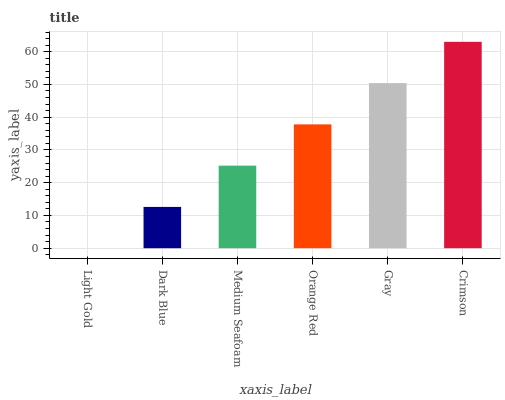Is Light Gold the minimum?
Answer yes or no. Yes. Is Crimson the maximum?
Answer yes or no. Yes. Is Dark Blue the minimum?
Answer yes or no. No. Is Dark Blue the maximum?
Answer yes or no. No. Is Dark Blue greater than Light Gold?
Answer yes or no. Yes. Is Light Gold less than Dark Blue?
Answer yes or no. Yes. Is Light Gold greater than Dark Blue?
Answer yes or no. No. Is Dark Blue less than Light Gold?
Answer yes or no. No. Is Orange Red the high median?
Answer yes or no. Yes. Is Medium Seafoam the low median?
Answer yes or no. Yes. Is Crimson the high median?
Answer yes or no. No. Is Crimson the low median?
Answer yes or no. No. 